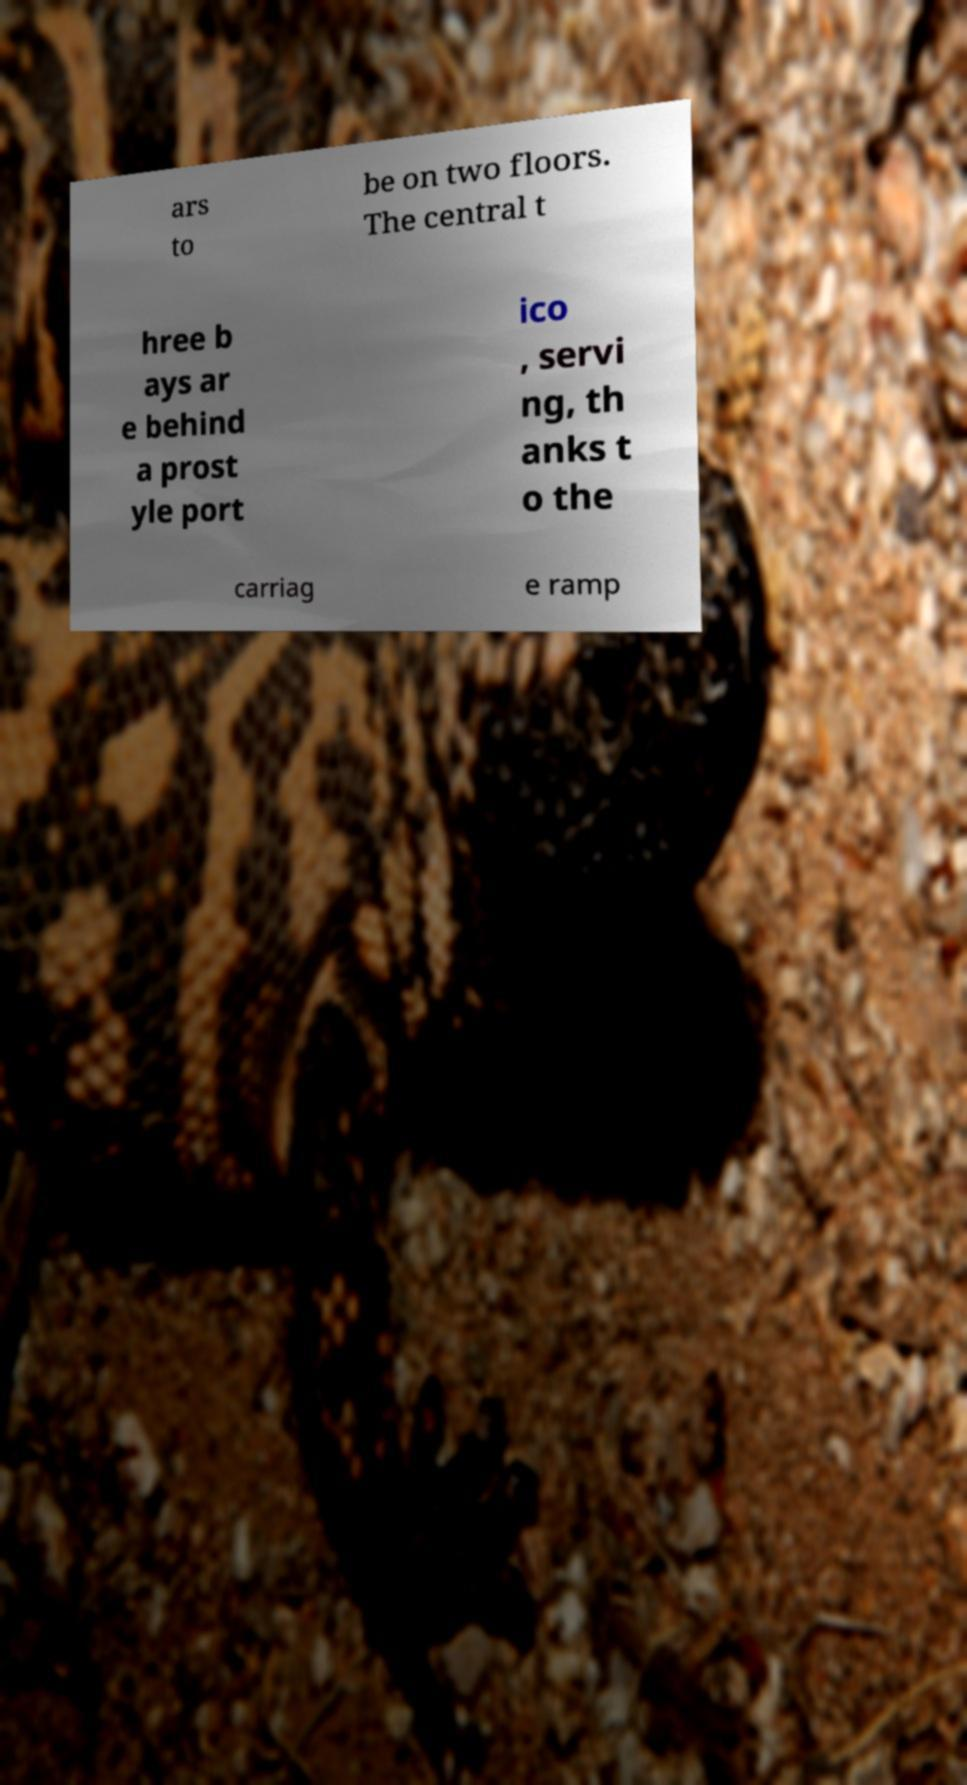I need the written content from this picture converted into text. Can you do that? ars to be on two floors. The central t hree b ays ar e behind a prost yle port ico , servi ng, th anks t o the carriag e ramp 